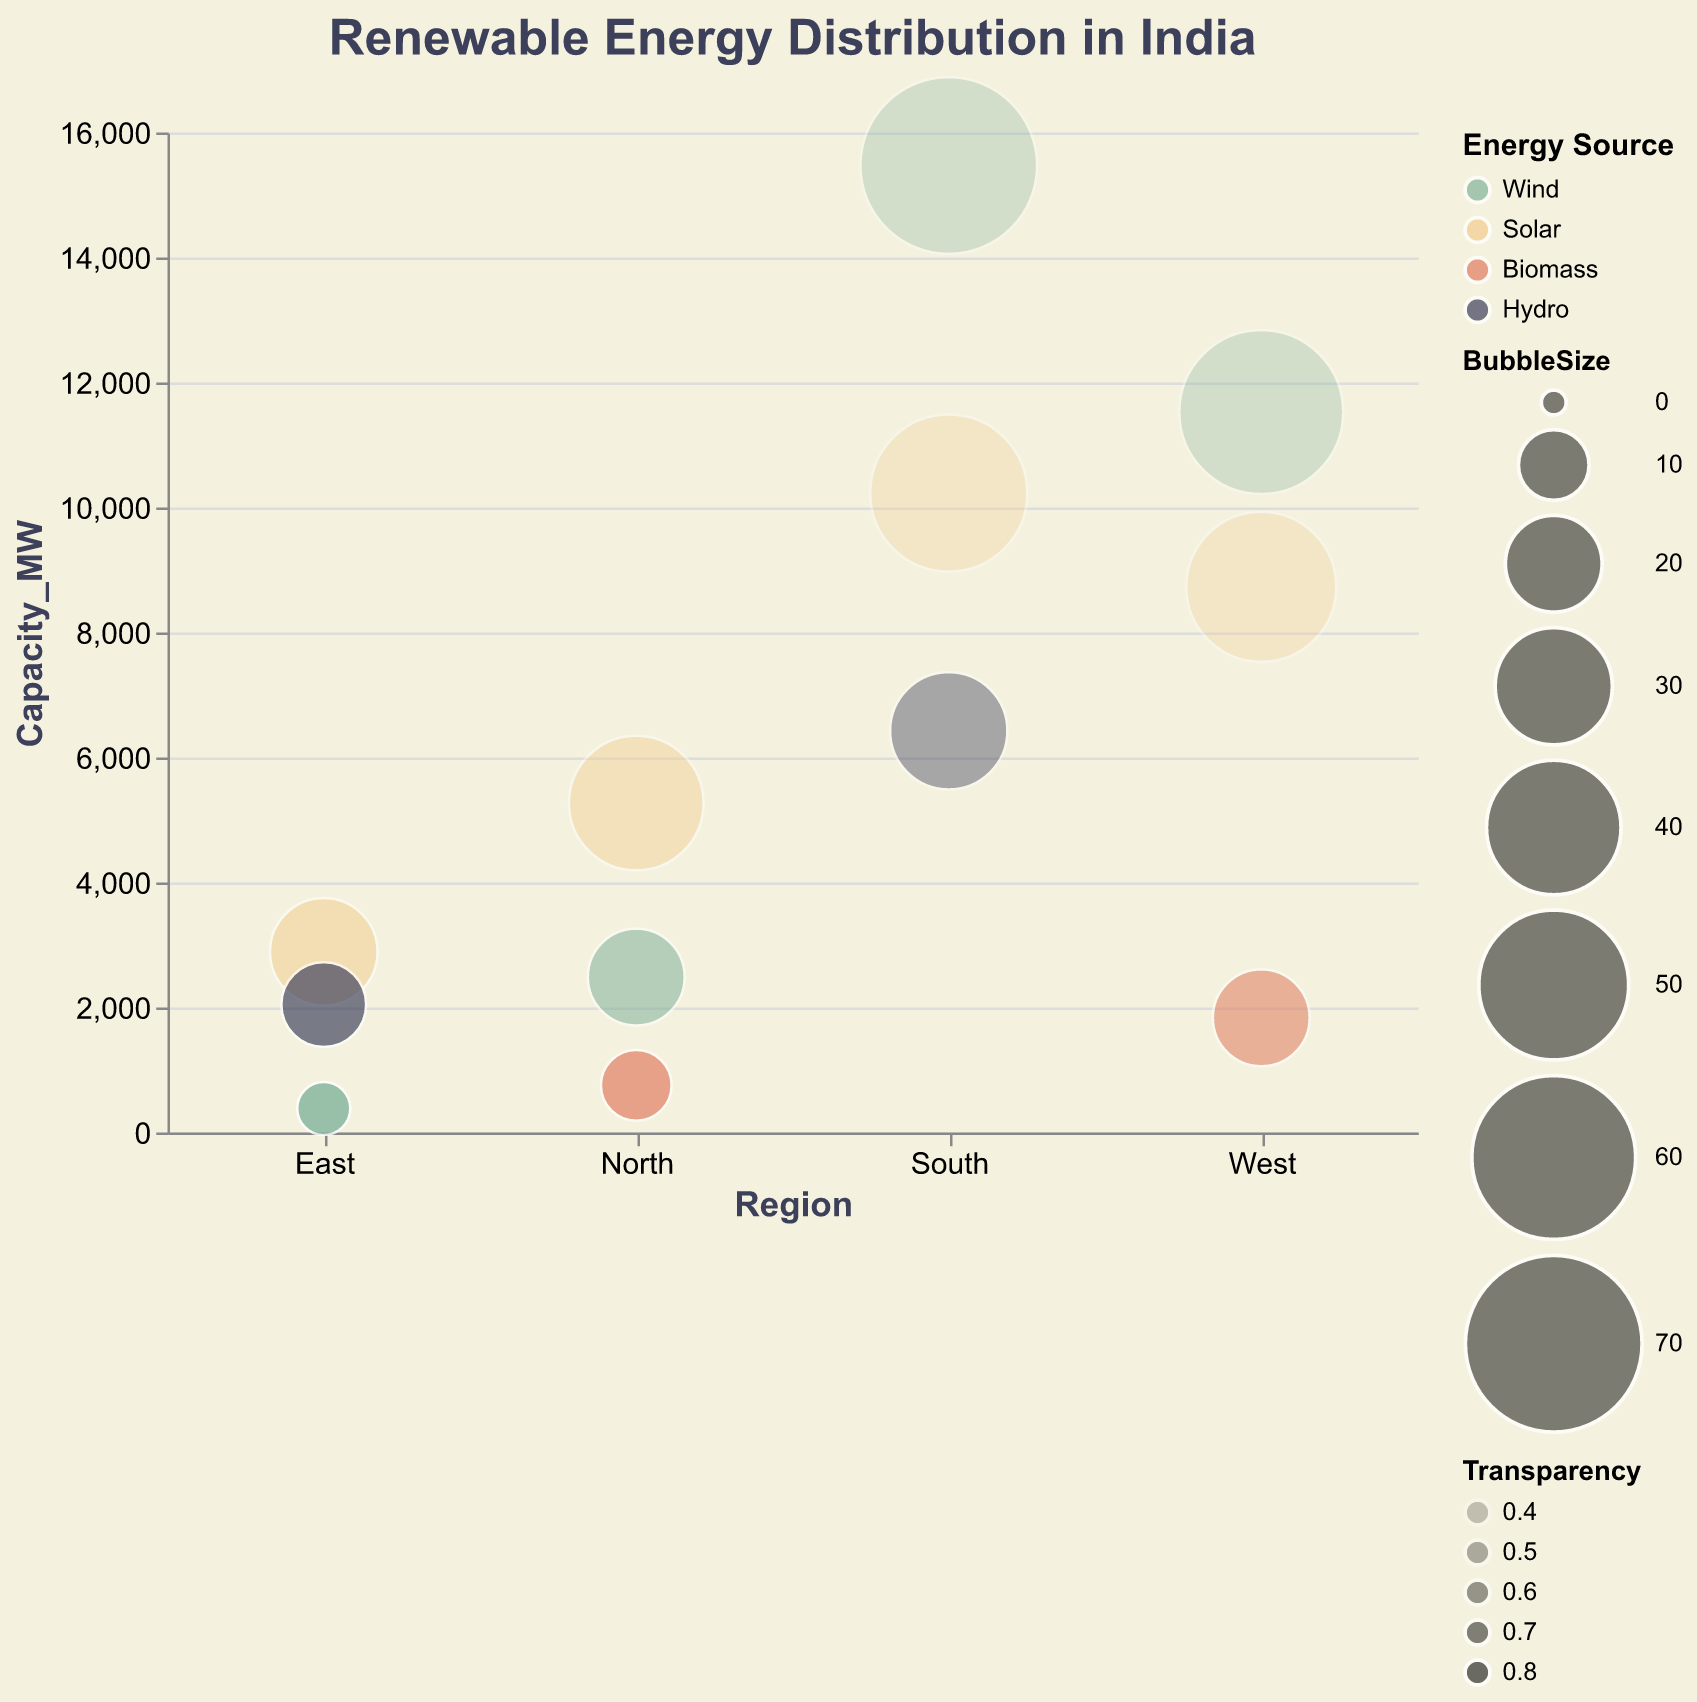What's the title of the figure? The title of the figure is displayed prominently at the top and reads "Renewable Energy Distribution in India".
Answer: Renewable Energy Distribution in India Which region has the highest capacity of wind energy? By examining the capacity values on the y-axis for the "Wind" energy source, the South region has the highest capacity, which is 15472 MW.
Answer: South What is the bubble size for solar energy in the North region? By looking at the "Region" (North) and "RenewableEnergySource" (Solar), the bubble size corresponding to it is 40.
Answer: 40 Which energy source has the highest capacity in the West region? The energy sources for the West region are "Wind", "Solar", and "Biomass". The capacities are 11527 MW (Wind), 8731 MW (Solar), and 1835 MW (Biomass), so the highest capacity is for "Wind".
Answer: Wind How does the transparency of hydro energy in the South region compare to that in the East region? The transparency values for Hydro in the South and East regions are 0.5 and 0.7 respectively. Since 0.5 is less than 0.7, the hydro energy bubble is less transparent in the South compared to the East.
Answer: Less transparent What is the total capacity of solar energy across all regions? Adding the capacities of solar energy from each region: 5271 MW (North) + 2891 MW (East) + 8731 MW (West) + 10231 MW (South) gives a total of 27124 MW.
Answer: 27124 MW Which region has the most diverse renewable energy sources? By counting the number of different energy sources in each region: North (3: Wind, Solar, Biomass), East (3: Wind, Solar, Hydro), West (3: Wind, Solar, Biomass), South (3: Wind, Solar, Hydro), all regions have an equal diversity of 3 sources.
Answer: All regions have equal diversity If you consider both capacity and bubble size, which region has the largest bubble for biomass energy? Biomass capacities and bubble sizes are: North (755 MW, size 10), West (1835 MW, size 20). The West has the largest bubble size for biomass energy.
Answer: West What can you infer about solar energy's capacity and its transparency in the South region? In the South region, the solar energy capacity is 10231 MW, and its transparency value is 0.4. This means the bubble representing solar energy would be quite large and less transparent.
Answer: 10231 MW, less transparent Which region has the smallest bubble size for wind energy? By comparing the bubble sizes for wind energy: North (20), East (5), West (60), South (70), the smallest bubble size for wind energy is in the East region.
Answer: East 